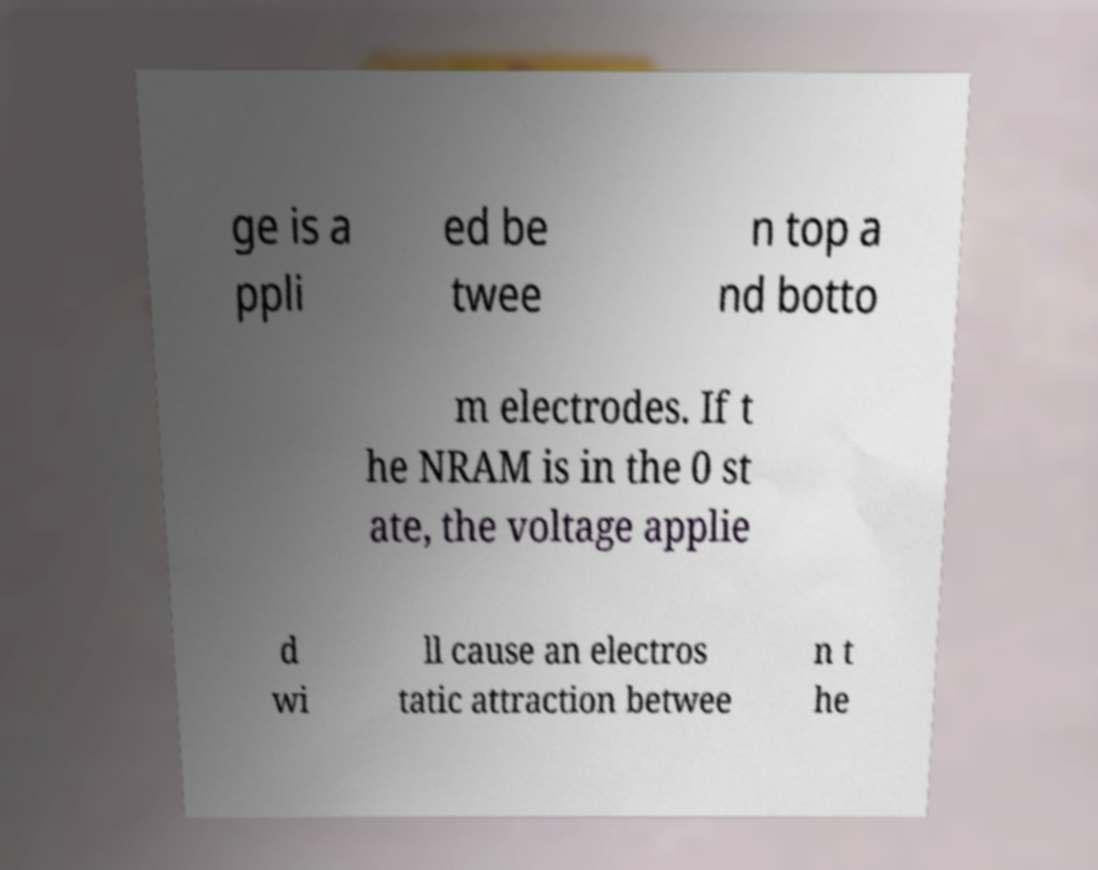What messages or text are displayed in this image? I need them in a readable, typed format. ge is a ppli ed be twee n top a nd botto m electrodes. If t he NRAM is in the 0 st ate, the voltage applie d wi ll cause an electros tatic attraction betwee n t he 